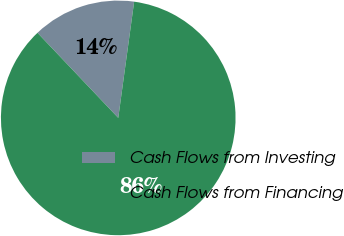Convert chart to OTSL. <chart><loc_0><loc_0><loc_500><loc_500><pie_chart><fcel>Cash Flows from Investing<fcel>Cash Flows from Financing<nl><fcel>14.25%<fcel>85.75%<nl></chart> 